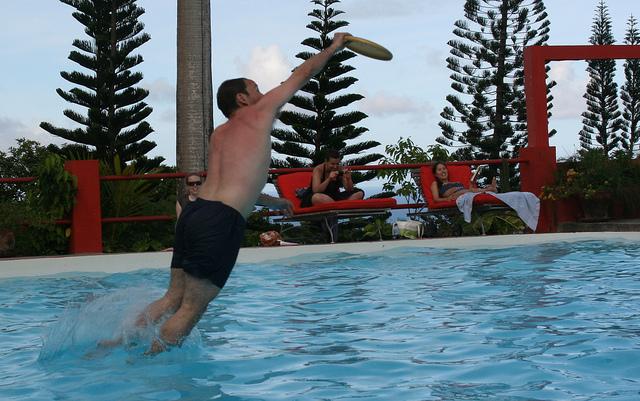What is the man catching?
Concise answer only. Frisbee. Is the man's feet on the ground?
Short answer required. No. What is the man doing?
Write a very short answer. Catching frisbee. 